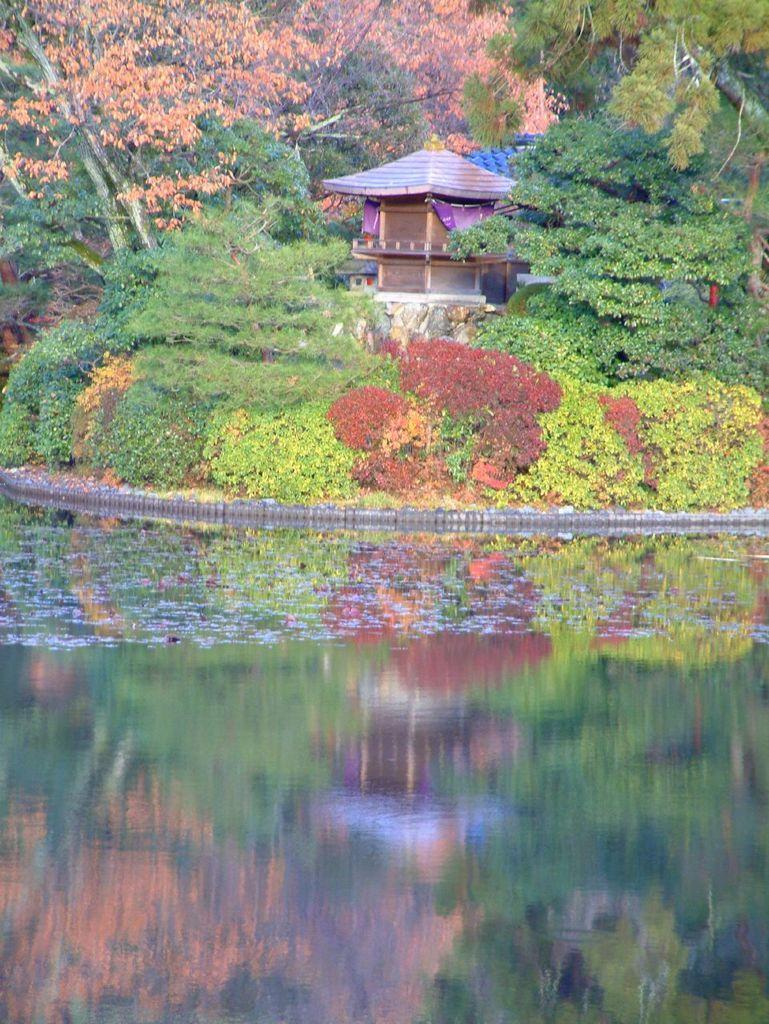What is the primary element visible in the image? There is water in the image. What other natural elements can be seen in the image? There are plants in the image. What can be seen in the background of the image? There are trees and a house in the background of the image. What type of feather can be seen floating on the water in the image? There is no feather visible in the image; it only features water, plants, trees, and a house in the background. 